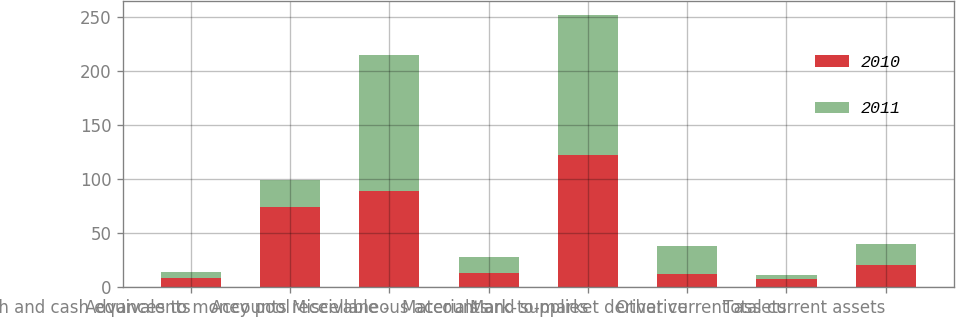<chart> <loc_0><loc_0><loc_500><loc_500><stacked_bar_chart><ecel><fcel>Cash and cash equivalents<fcel>Advances to money pool<fcel>Accounts receivable -<fcel>Miscellaneous accounts<fcel>Materials and supplies<fcel>Mark-to-market derivative<fcel>Other current assets<fcel>Total current assets<nl><fcel>2010<fcel>8<fcel>74<fcel>89<fcel>13<fcel>122<fcel>12<fcel>7<fcel>20<nl><fcel>2011<fcel>6<fcel>25<fcel>126<fcel>15<fcel>130<fcel>26<fcel>4<fcel>20<nl></chart> 